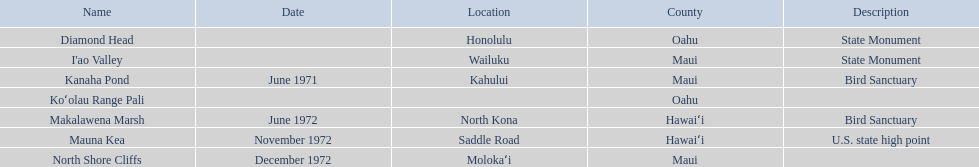Can you mention a location in hawaii besides mauna kea? Makalawena Marsh. 